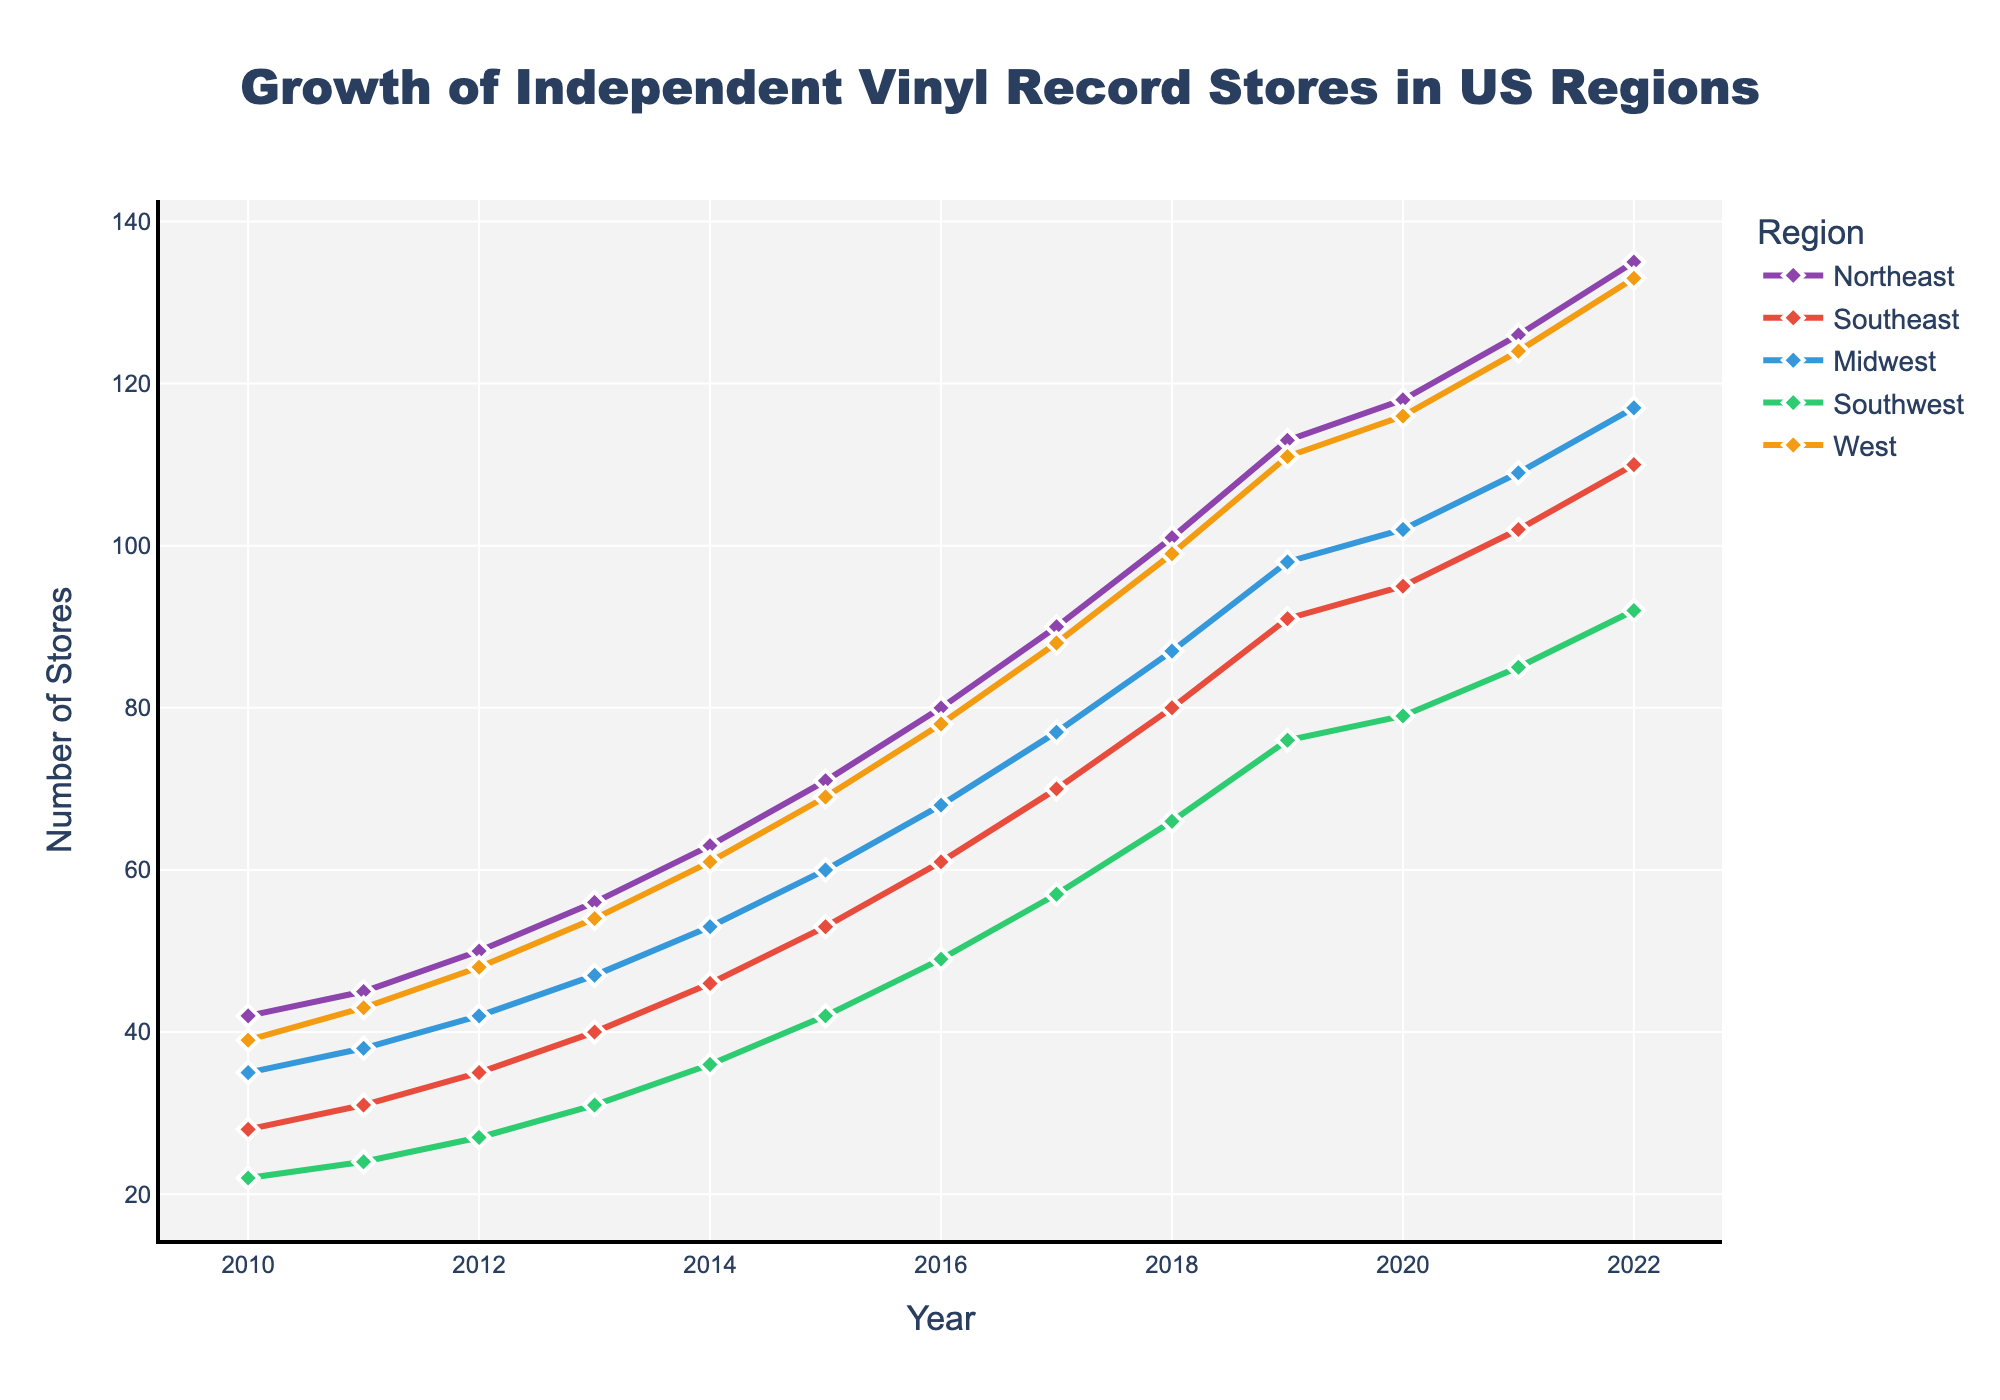what is the highest number of stores in any region in the latest year? The latest year in the data is 2022. By looking at 2022, the highest number of stores across the regions are: Northeast (135), Southeast (110), Midwest (117), Southwest (92), and West (133). Among these, the Northeast has the highest number at 135.
Answer: 135 Which region showed the most growth from 2010 to 2022? Calculate the difference in the number of stores between 2022 and 2010 for each region: Northeast (135-42=93), Southeast (110-28=82), Midwest (117-35=82), Southwest (92-22=70), and West (133-39=94). The West showed the most growth with an increase of 94 stores.
Answer: West What is the average number of stores in the Midwest over the given period? Add the number of stores in the Midwest from each year and divide by the number of years: (35+38+42+47+53+60+68+77+87+98+102+109+117)/13. Sum is 835. Average = 835/13 ≈ 64.2.
Answer: 64.2 Between which consecutive years did the Southeast experience the highest increase in stores? Calculate the yearly difference for the Southeast: 2010 to 2011 (31-28=3), 2011 to 2012 (35-31=4), 2012 to 2013 (40-35=5), 2013 to 2014 (46-40=6), 2014 to 2015 (53-46=7), 2015 to 2016 (61-53=8), 2016 to 2017 (70-61=9), 2017 to 2018 (80-70=10), 2018 to 2019 (91-80=11), 2019 to 2020 (95-91=4), 2020 to 2021 (102-95=7), 2021 to 2022 (110-102=8). The highest increase is 11 stores from 2018 to 2019.
Answer: 2018 to 2019 Which region had the lowest number of stores in 2016? By looking at the data for the year 2016: Northeast (80), Southeast (61), Midwest (68), Southwest (49), and West (78). The Southwest had the lowest number of stores at 49.
Answer: Southwest Is the growth trend in the West region linear over the years? From 2010 to 2022, plot the data points for the West. The number of stores grows from 39 to 133. The growth isn't strictly linear as the rate of increase varies over different periods, reflecting both steeper and more gradual rises.
Answer: No Compare the number of stores in the Northeast with the West in 2015. Which region had more stores? For the year 2015, the Northeast had 71 stores, and the West had 69 stores. The Northeast had more stores than the West in 2015.
Answer: Northeast 